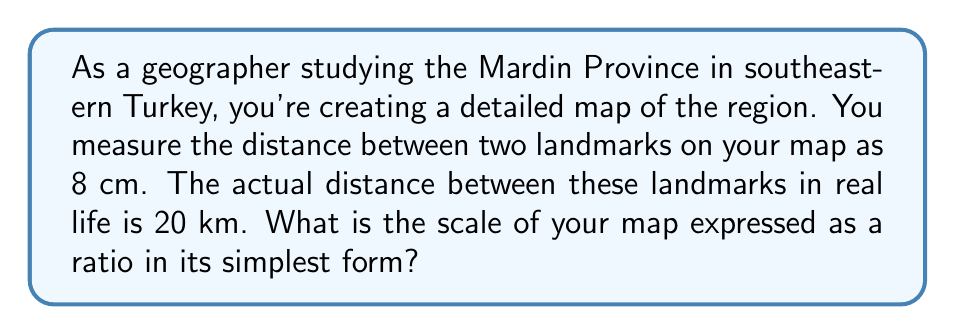Provide a solution to this math problem. To determine the scale of the map, we need to set up a ratio between the distance on the map and the actual distance in real life. However, we must ensure that both measurements are in the same units before we can simplify the ratio.

Let's convert the real-life distance to centimeters:
20 km = 20,000 m = 2,000,000 cm

Now we can set up our ratio:
Map distance : Actual distance
8 cm : 2,000,000 cm

To express this as a scale, we need to reduce the right side of the ratio to 1:
$\frac{8}{2,000,000} = \frac{1}{x}$

Cross multiply:
$8x = 2,000,000$

Solve for x:
$x = \frac{2,000,000}{8} = 250,000$

Therefore, the scale is 1:250,000, which means 1 cm on the map represents 250,000 cm in real life.

To verify:
$\frac{1 \text{ cm on map}}{250,000 \text{ cm in real life}} = \frac{8 \text{ cm on map}}{2,000,000 \text{ cm in real life}}$

This ratio is already in its simplest form as 1 and 250,000 have no common factors other than 1.
Answer: 1:250,000 